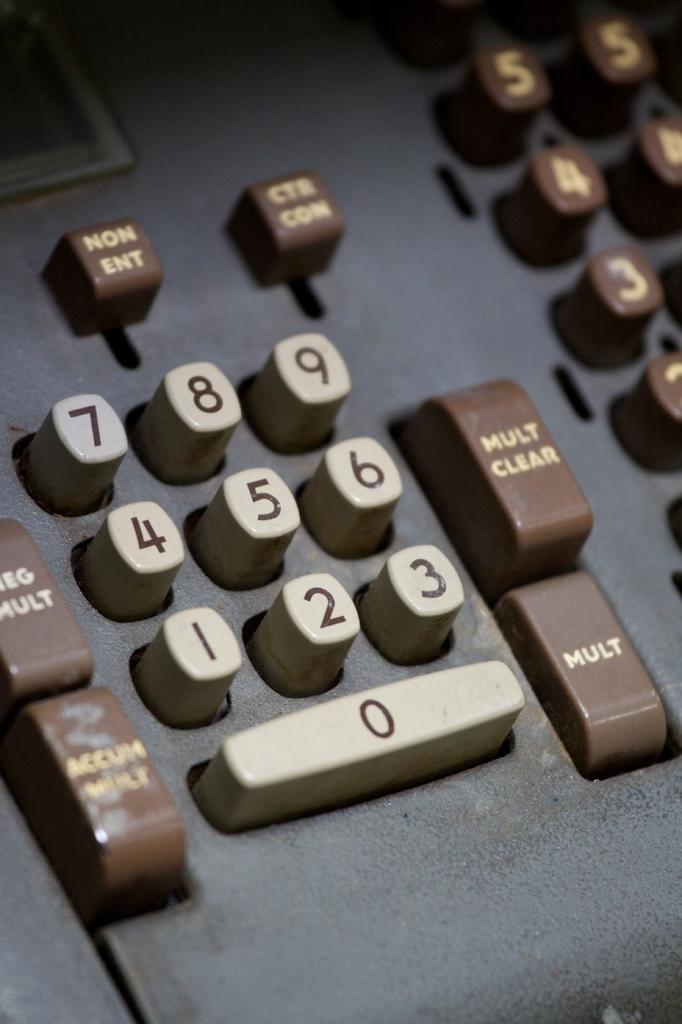What is the value on the long thin button at the bottom?
Offer a very short reply. 0. What does the bottom right button do?
Provide a succinct answer. Mult. 